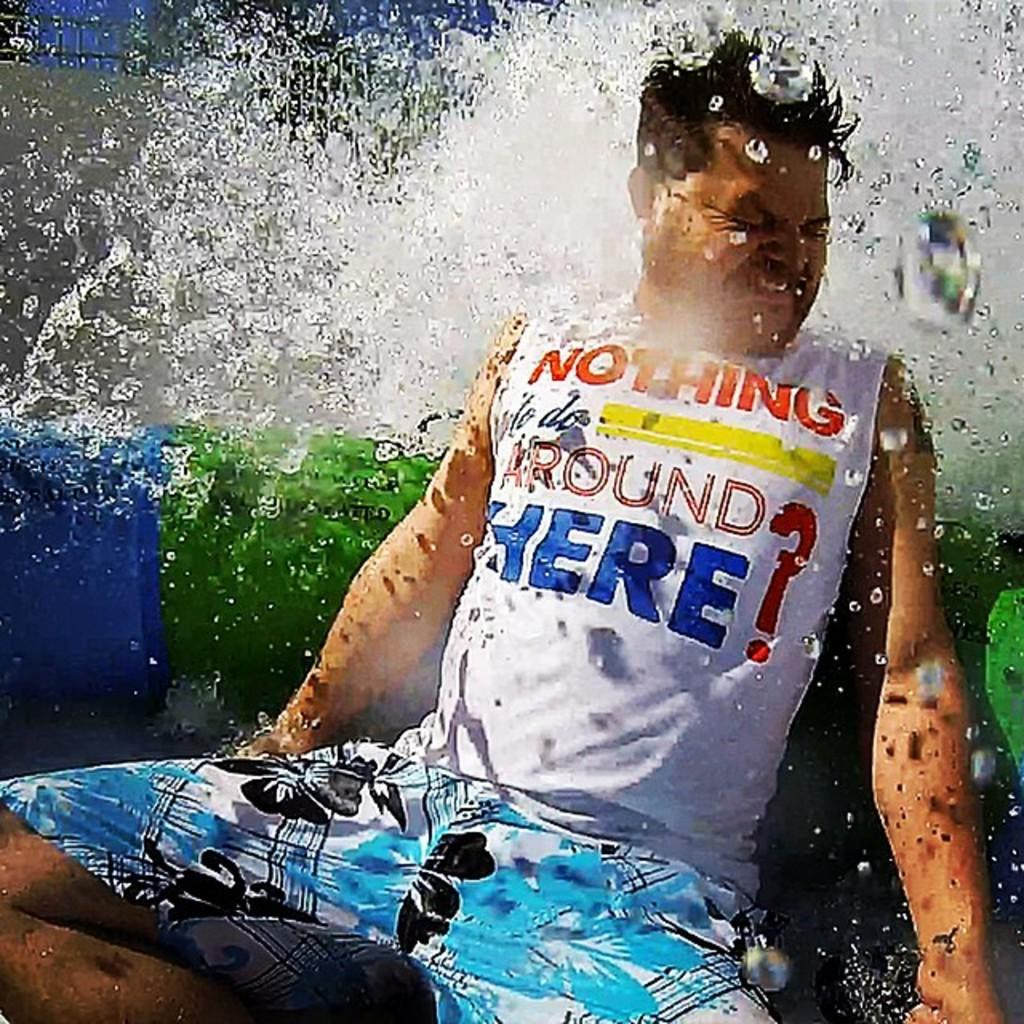Who is present in the image? There is a man in the image. What is located behind the man? There is an object behind the man. What can be seen towards the left of the image? There is a wall towards the left of the image. What is visible towards the top of the image? There is the sky towards the top of the image. What natural element is visible in the image? There is water visible in the image. What hobbies does the man have, as indicated by the cap he is wearing in the image? There is no cap visible in the image, and therefore no information about the man's hobbies can be inferred from it. 